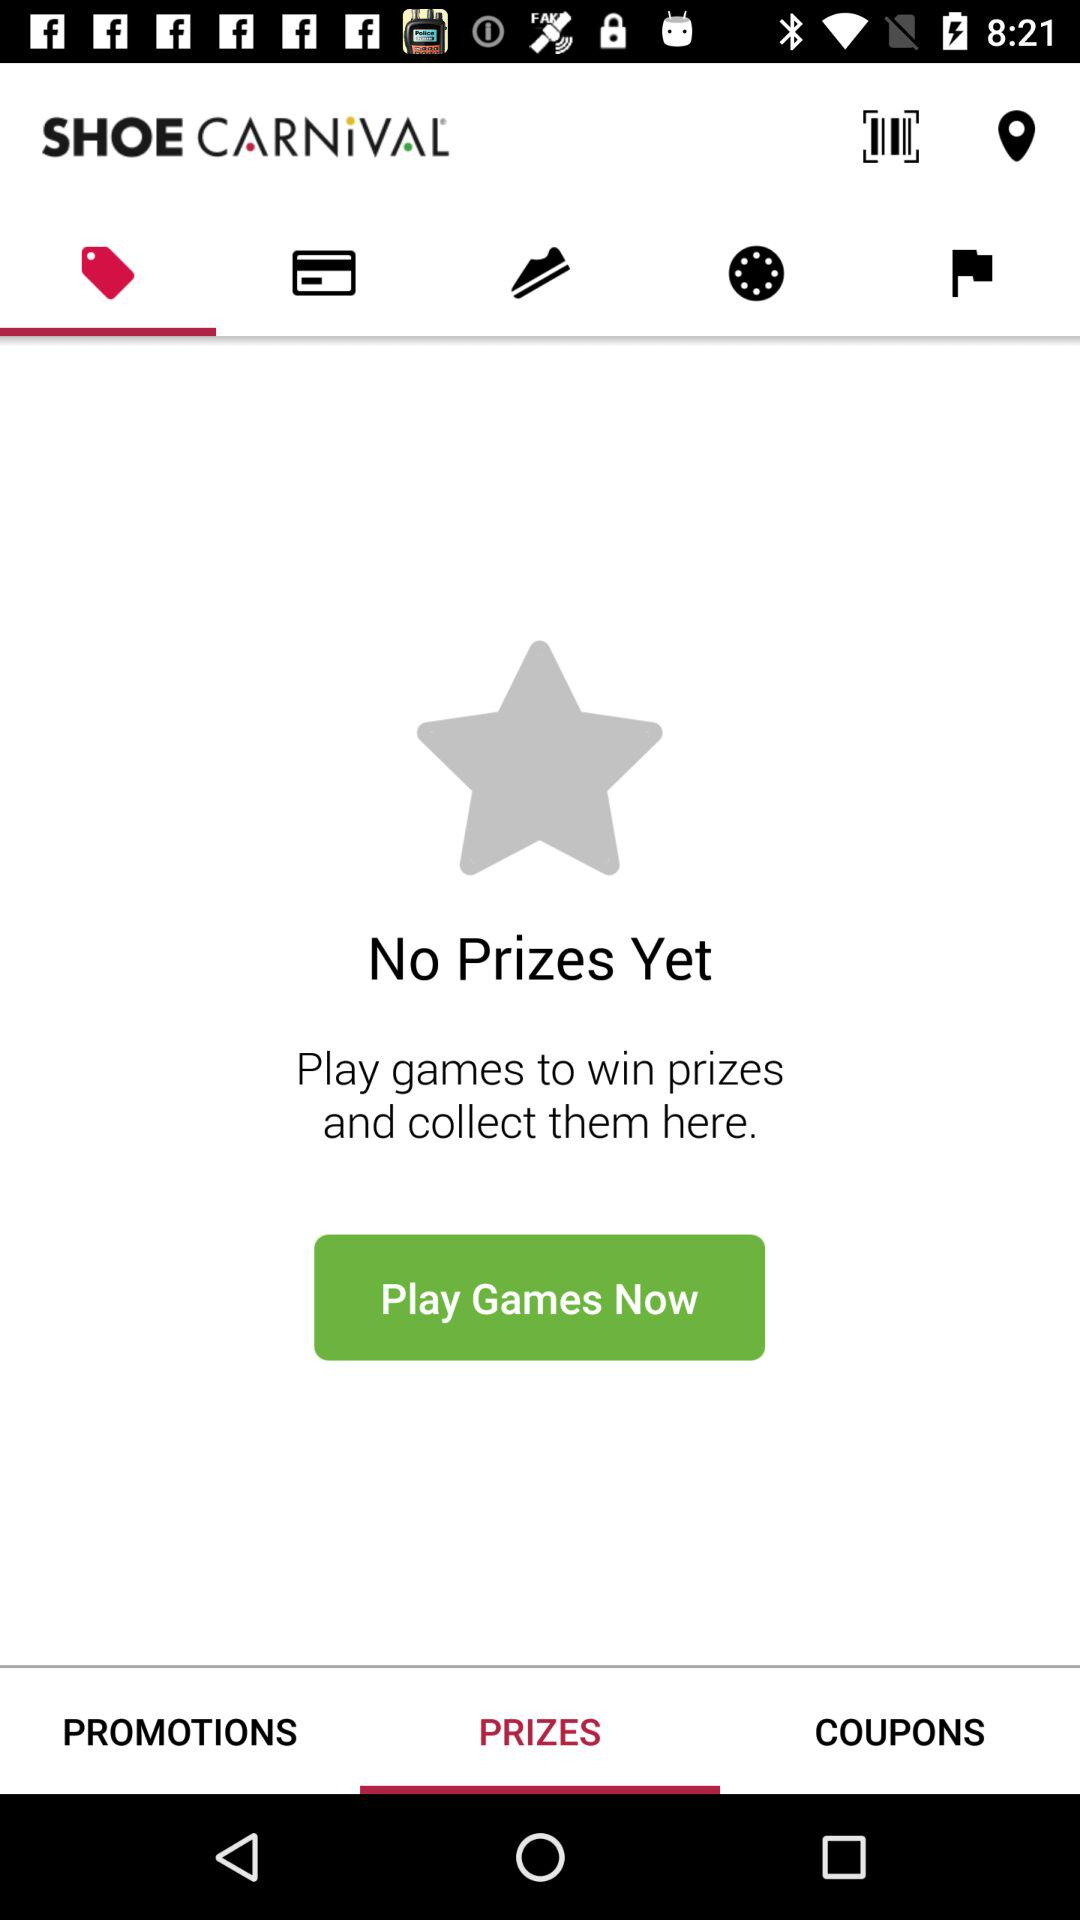How many promotions are there?
When the provided information is insufficient, respond with <no answer>. <no answer> 